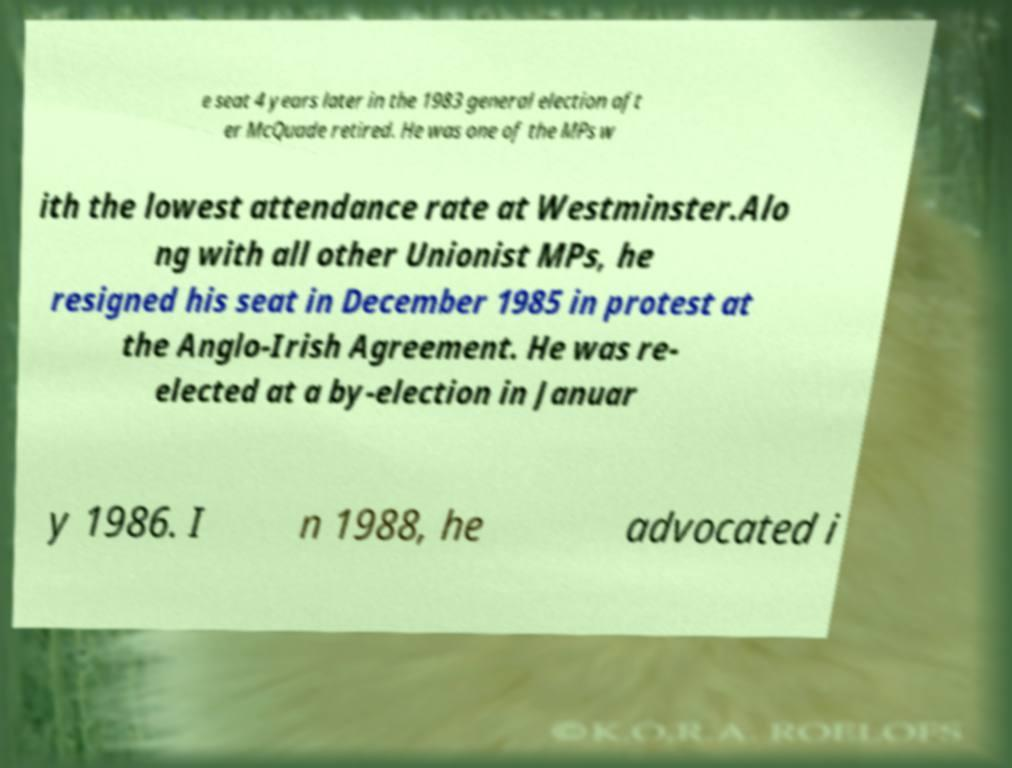Could you extract and type out the text from this image? e seat 4 years later in the 1983 general election aft er McQuade retired. He was one of the MPs w ith the lowest attendance rate at Westminster.Alo ng with all other Unionist MPs, he resigned his seat in December 1985 in protest at the Anglo-Irish Agreement. He was re- elected at a by-election in Januar y 1986. I n 1988, he advocated i 